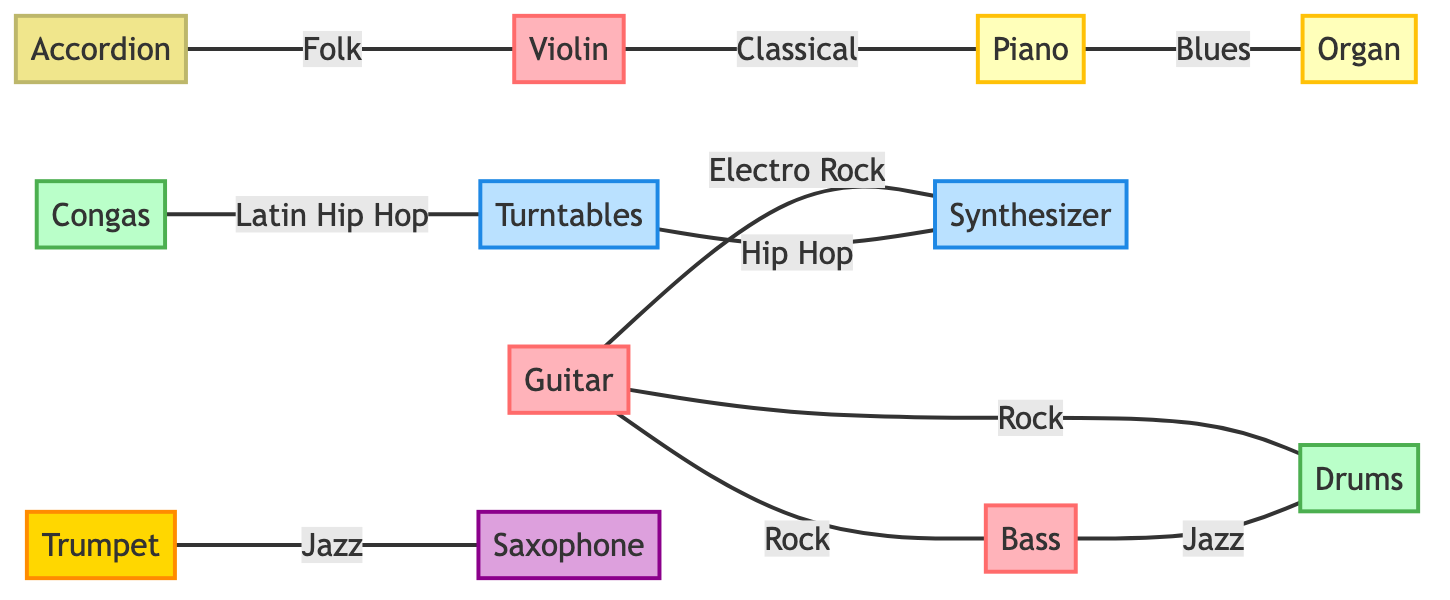What is the total number of instrument types represented in the diagram? The diagram lists a total of 12 distinct instrument types, such as Guitar, Bass, and Piano, shown as individual nodes. Counting these gives a total of 12.
Answer: 12 Which instrument connects with the most genres? Analyzing the links, the Guitar connects with Bass, Drums, and Synthesizer across three genres (Rock, Electro Rock), indicating it has the highest connections relative to genre.
Answer: Guitar In which genre is the Violin linked to the Piano? The diagram shows a direct link between the Violin and Piano under the context of Classical music. This is indicated in the relationship drawn in the graph.
Answer: Classical How many connections does the Synthesizer have? The Synthesizer has two connections: one to the Guitar in Electro Rock and another to Turntables in Hip Hop, counting these gives a total of 2 connections.
Answer: 2 Which two instruments are connected by the genre Jazz? The diagram explicitly shows a connection between Bass and Drums within the Jazz genre, as represented by the link in the graph.
Answer: Bass and Drums How many types of percussion instruments are listed in the diagram? The diagram includes two percussion instruments: Drums and Congas. By examining the node section, we can see both instruments categorized under percussion.
Answer: 2 What category does the Accordion belong to? The Accordion is identified in the diagram as a Folk Instrument, as noted in the group designation within the node description.
Answer: Folk Instruments Which two electronic instruments are linked in the Hip Hop genre? The Turntables are directly linked to the Synthesizer under the context of Hip Hop according to the connections made in the diagram.
Answer: Turntables and Synthesizer Which instrument type connects both Brass and Woodwind instruments? The Trumpet connects with the Saxophone in the context of Jazz, effectively linking a brass and a woodwind instrument through this relationship.
Answer: Trumpet and Saxophone 